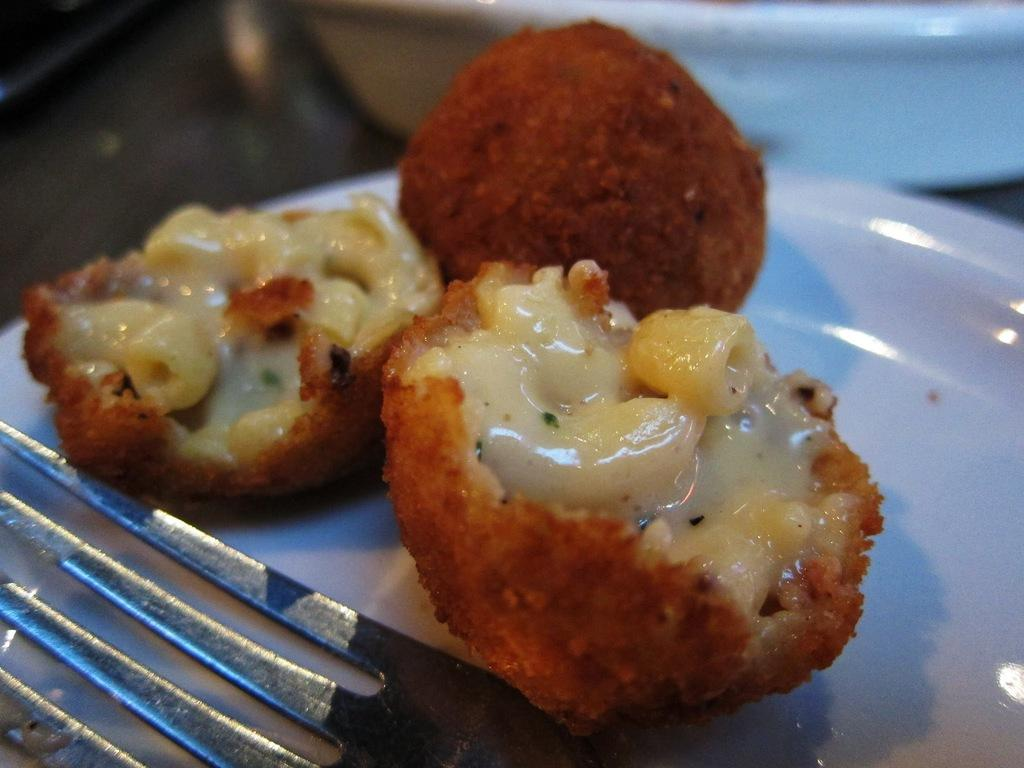What is the main subject of the image? The main subject of the image is food. What is the color of the surface on which the food is placed? The food is on a white color palette. What utensil is present in the image? There is a fork in the plate. What type of circle is being discussed in the meeting in the image? There is no meeting or circle present in the image; it features food on a white color palette with a fork. 